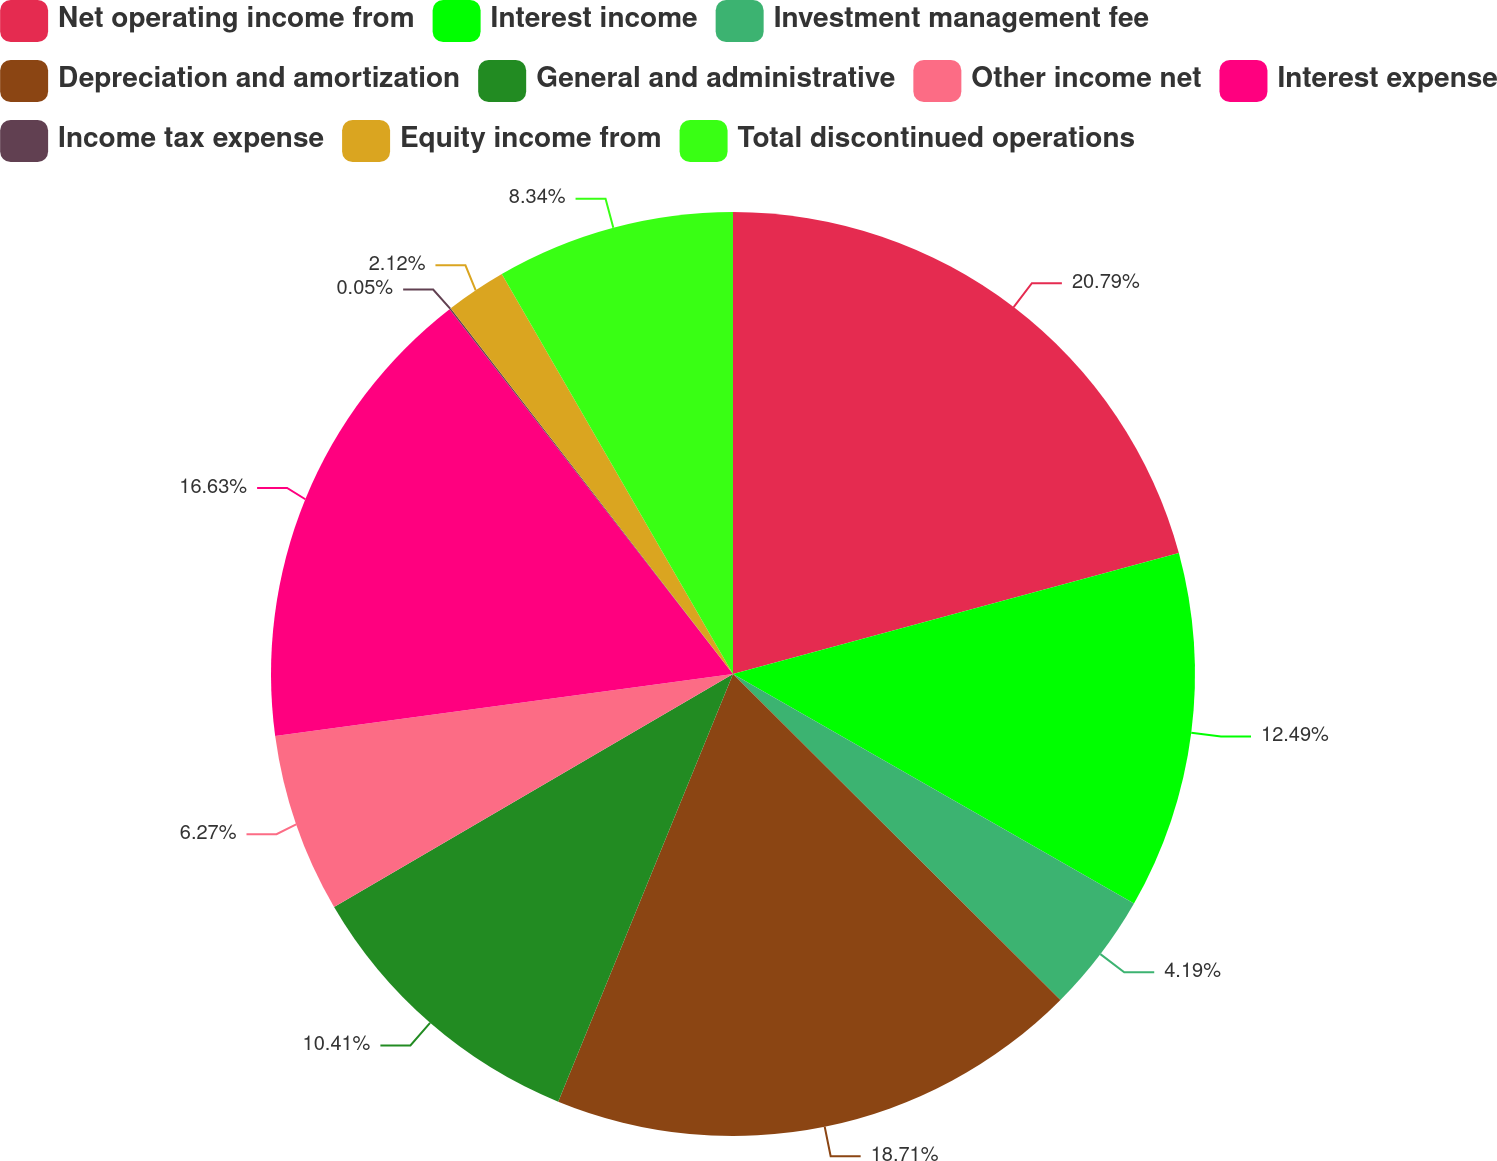Convert chart to OTSL. <chart><loc_0><loc_0><loc_500><loc_500><pie_chart><fcel>Net operating income from<fcel>Interest income<fcel>Investment management fee<fcel>Depreciation and amortization<fcel>General and administrative<fcel>Other income net<fcel>Interest expense<fcel>Income tax expense<fcel>Equity income from<fcel>Total discontinued operations<nl><fcel>20.78%<fcel>12.49%<fcel>4.19%<fcel>18.71%<fcel>10.41%<fcel>6.27%<fcel>16.63%<fcel>0.05%<fcel>2.12%<fcel>8.34%<nl></chart> 